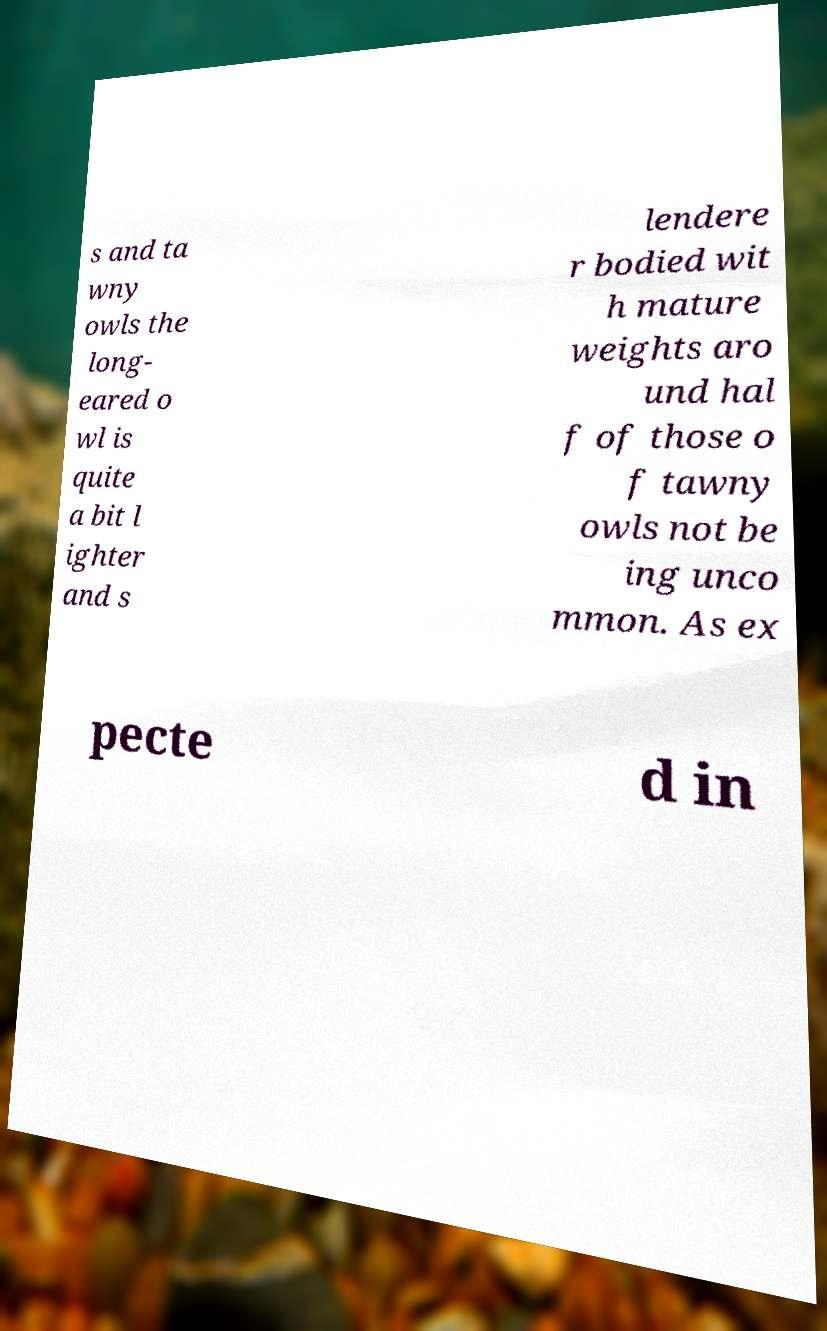Can you read and provide the text displayed in the image?This photo seems to have some interesting text. Can you extract and type it out for me? s and ta wny owls the long- eared o wl is quite a bit l ighter and s lendere r bodied wit h mature weights aro und hal f of those o f tawny owls not be ing unco mmon. As ex pecte d in 